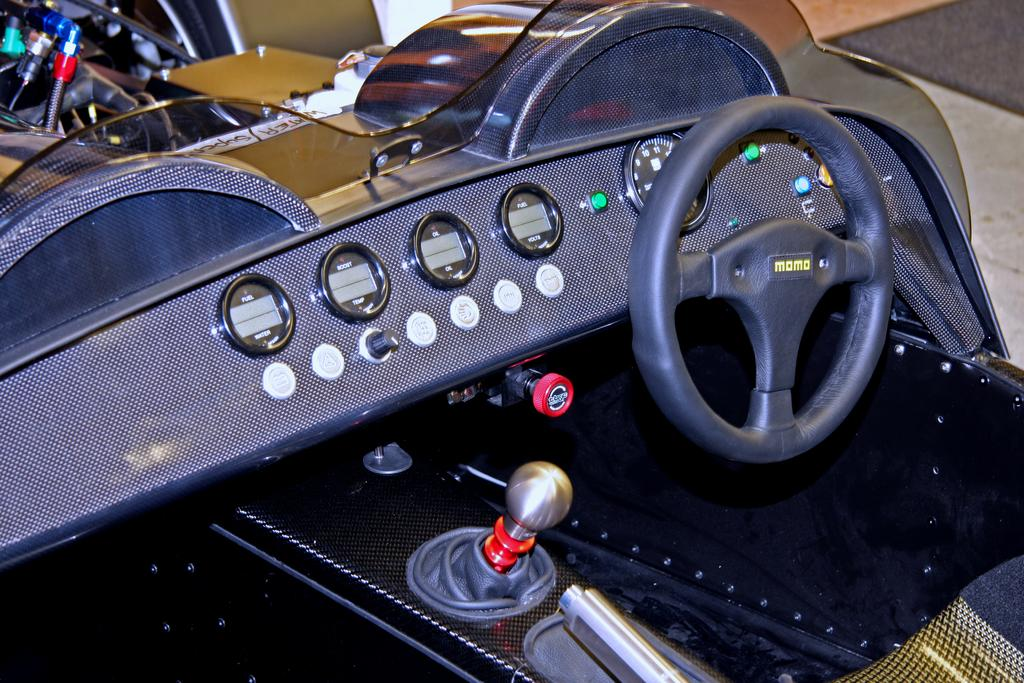What is the main object in the image? There is a steering wheel in the image. What instrument is located behind the steering wheel? There is a speedometer behind the steering wheel. What can be used to change gears in the vehicle? There is a gear rod on the left side of the image. What other objects can be seen in front of the vehicle? There are other objects visible in front of the vehicle, but their specific details are not mentioned in the provided facts. What type of holiday is being celebrated in the image? There is no indication of a holiday being celebrated in the image; it primarily features a steering wheel, speedometer, and gear rod. 